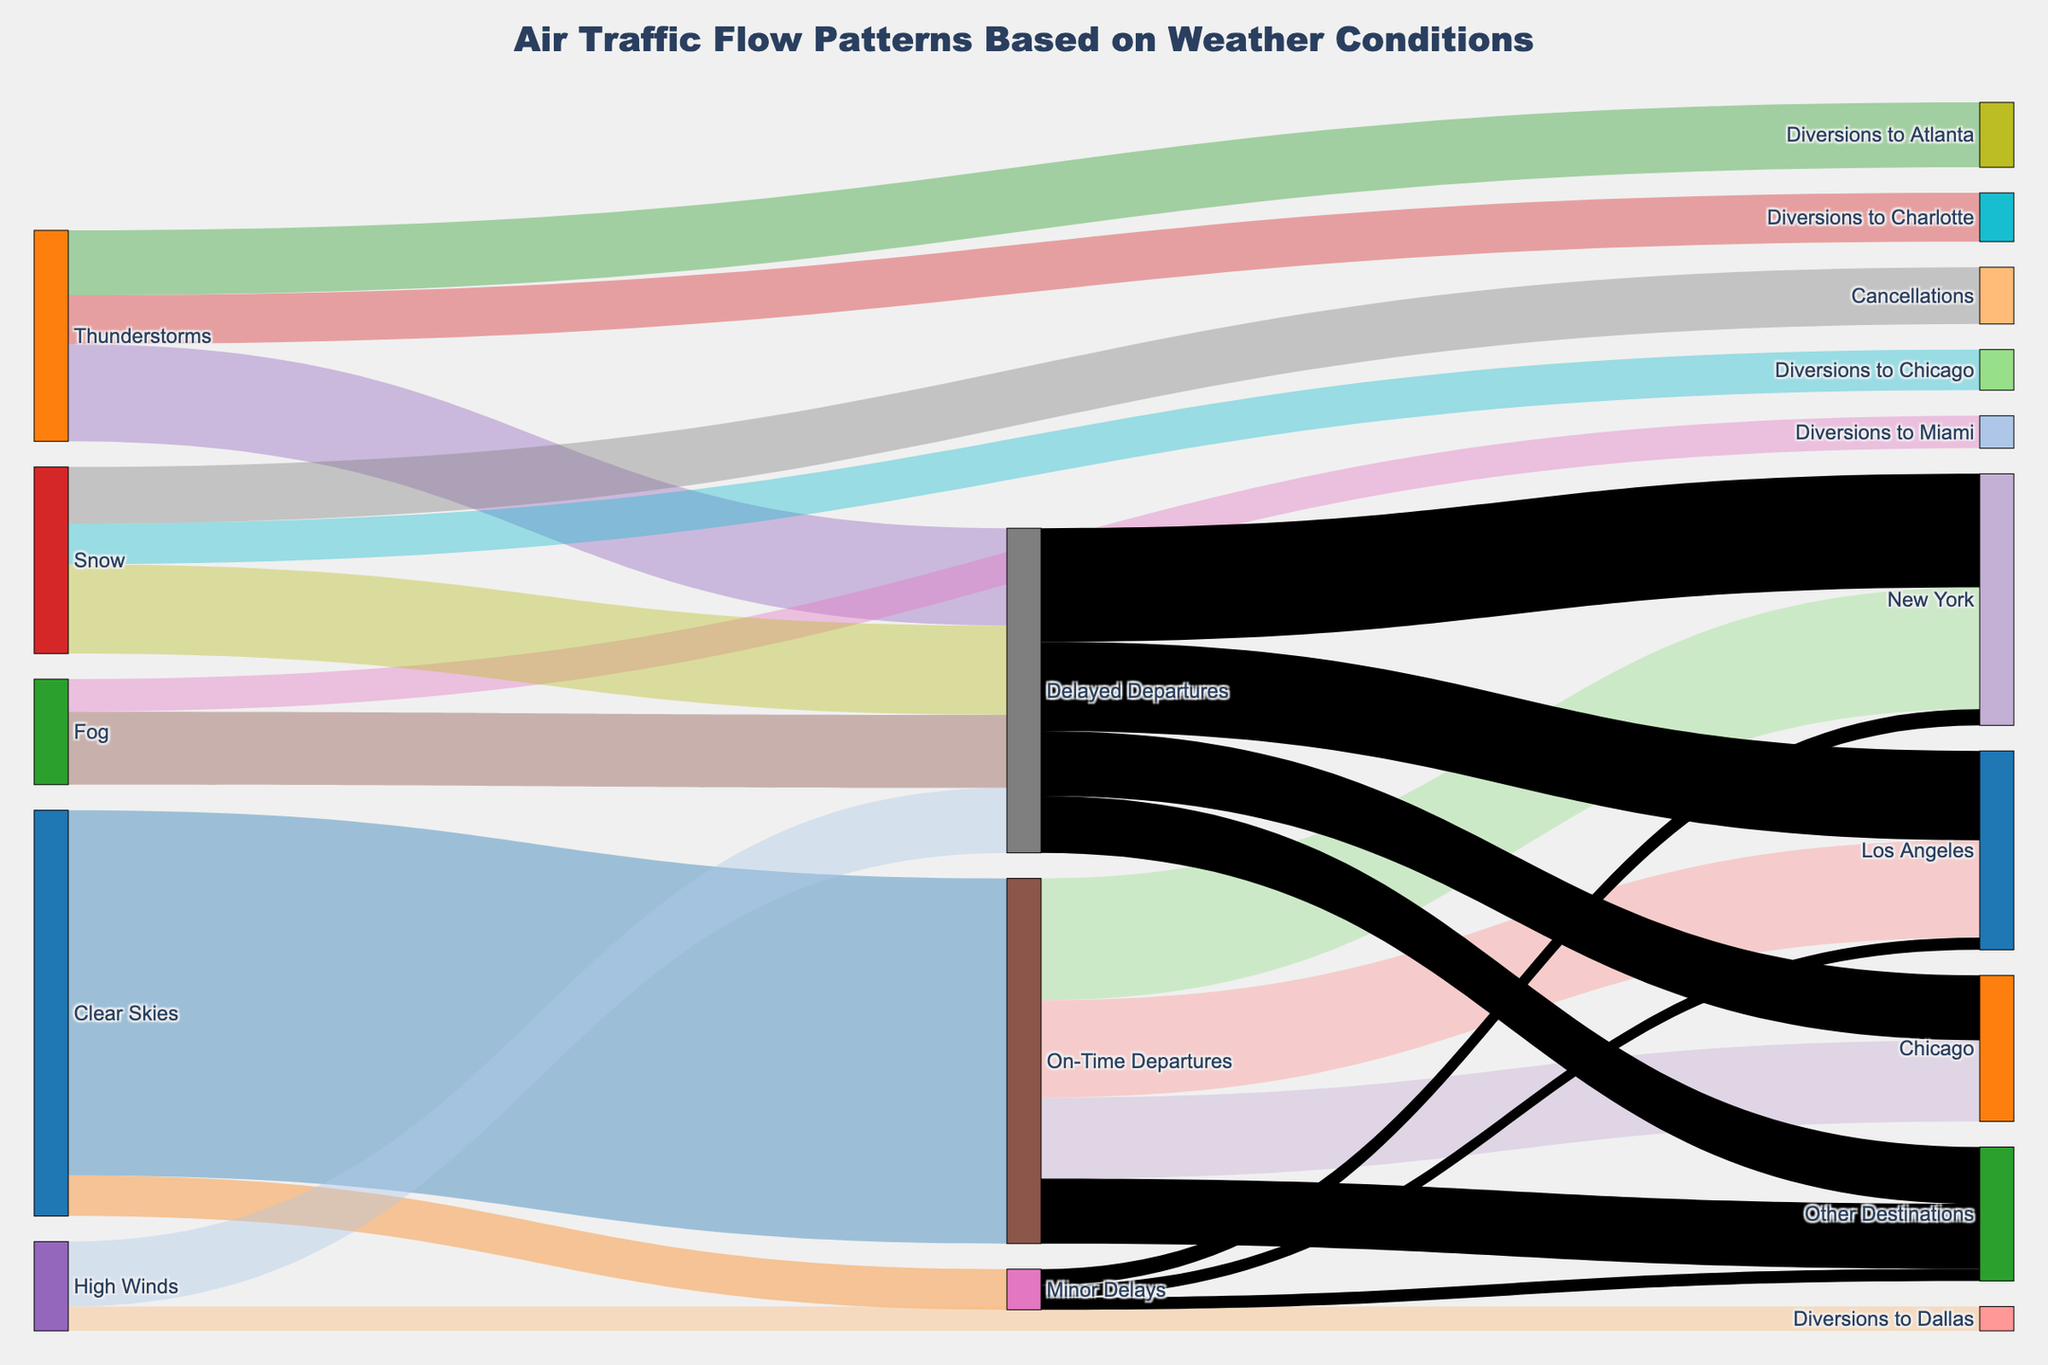What's the dominant weather condition leading to on-time departures? By observing the diagram, you can see that clear skies feed mostly into on-time departures. Other weather conditions don't lead to on-time departures.
Answer: Clear skies How many destinations are affected by minor delays? The diagram shows that minor delays lead to three destinations: New York, Los Angeles, and Other Destinations. By adding the values (20+15+15), we get a total of 50.
Answer: 50 Which weather condition results in the highest number of diversions? Thunderstorms result in the highest number of diversions compared to other weather conditions. Adding diversions to Atlanta (80) and Charlotte (60), we get a total of 140.
Answer: Thunderstorms Which destination receives the highest number of delayed departures? By tracking the flows from delayed departures, New York receives the highest number (140), compared to other destinations.
Answer: New York Between snow and high winds, which causes more canceled flights? The diagram shows that snow causes cancellations, but high winds do not.
Answer: Snow What is the combined effect of fog on air traffic? Fog causes delayed departures (90) and diversions to Miami (40), resulting in a combined effect of 130.
Answer: 130 How do the effects of clear skies compare with the effects of thunderstorms on air traffic? Clear skies primarily lead to on-time departures (450) and minor delays (50). Thunderstorms, however, result in diversions to Atlanta (80), Charlotte (60), and delayed departures (120), summing up to 260. Clear skies have a more positive effect, reducing delays and diversions.
Answer: Clear skies have a more positive effect Which destinations receive flights affected by delays but not by on-time departures? From the diagram, the destination 'Other Destinations' and New York are shown under delayed departures but not directly under on-time departures. This can be inferred since 'Other Destinations' have flights delayed not on-time.
Answer: Other Destinations 